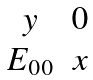<formula> <loc_0><loc_0><loc_500><loc_500>\begin{matrix} y & 0 \\ E _ { 0 0 } & x \end{matrix}</formula> 